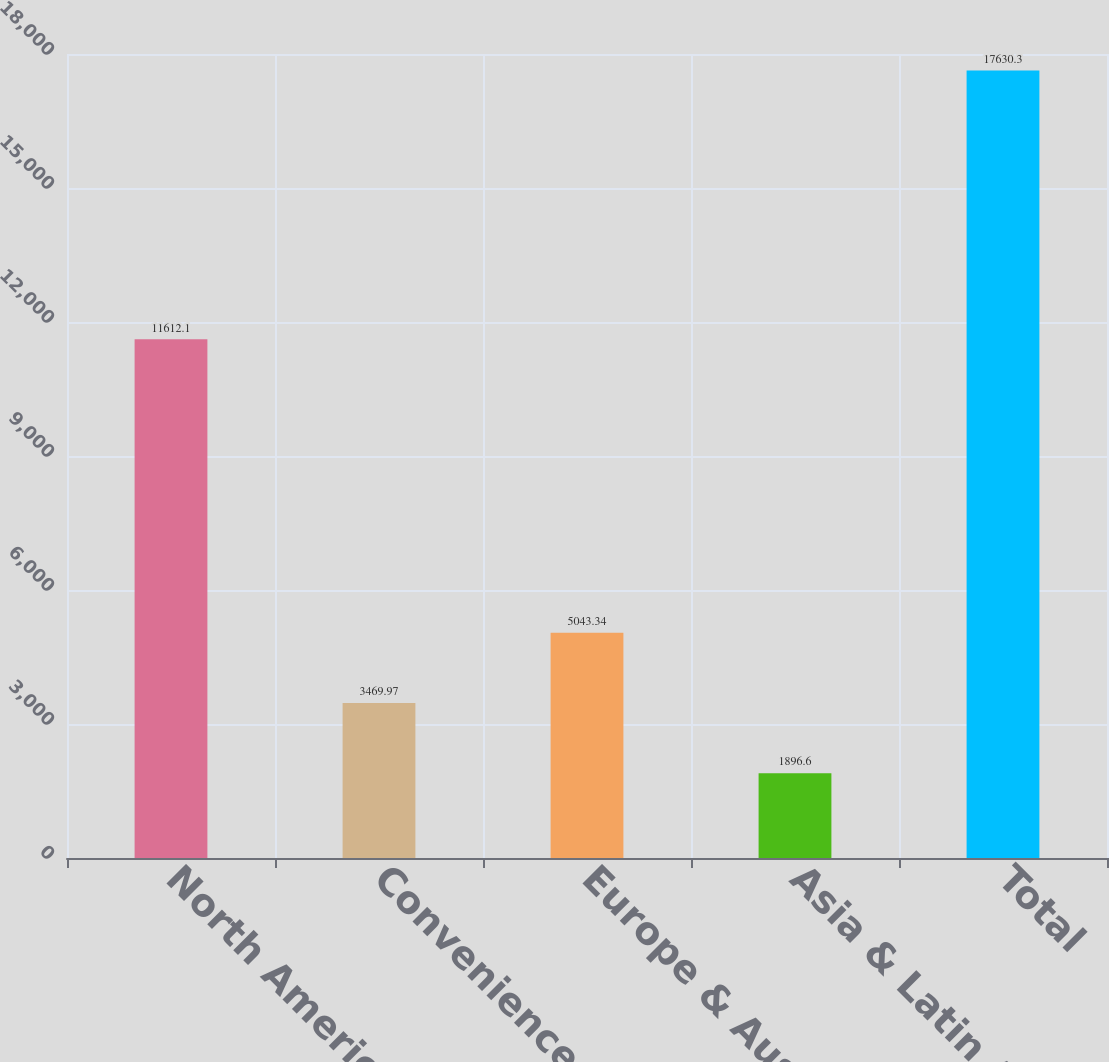<chart> <loc_0><loc_0><loc_500><loc_500><bar_chart><fcel>North America Retail<fcel>Convenience Stores &<fcel>Europe & Australia<fcel>Asia & Latin America<fcel>Total<nl><fcel>11612.1<fcel>3469.97<fcel>5043.34<fcel>1896.6<fcel>17630.3<nl></chart> 